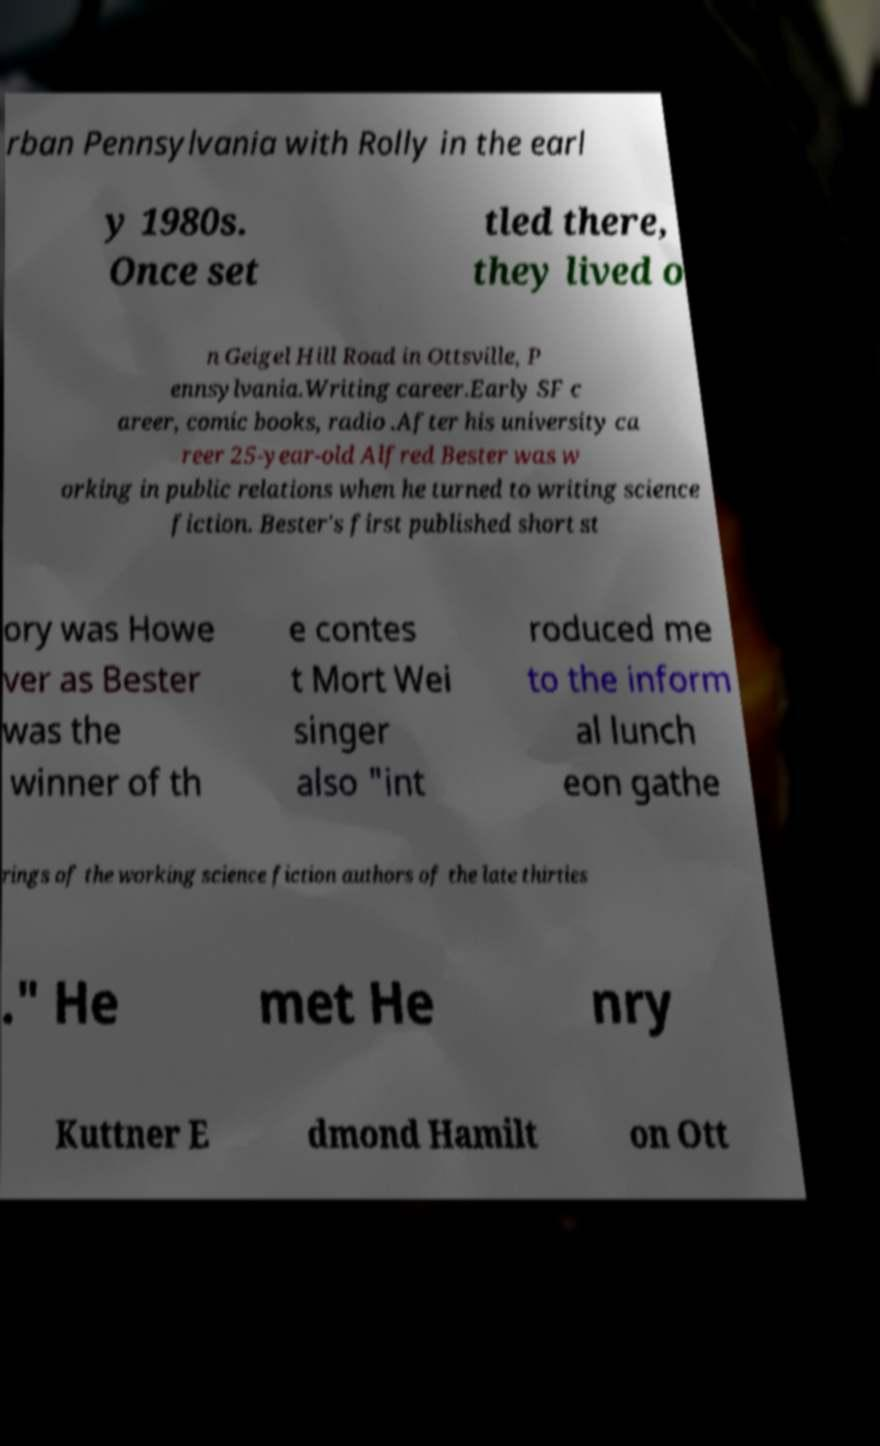There's text embedded in this image that I need extracted. Can you transcribe it verbatim? rban Pennsylvania with Rolly in the earl y 1980s. Once set tled there, they lived o n Geigel Hill Road in Ottsville, P ennsylvania.Writing career.Early SF c areer, comic books, radio .After his university ca reer 25-year-old Alfred Bester was w orking in public relations when he turned to writing science fiction. Bester's first published short st ory was Howe ver as Bester was the winner of th e contes t Mort Wei singer also "int roduced me to the inform al lunch eon gathe rings of the working science fiction authors of the late thirties ." He met He nry Kuttner E dmond Hamilt on Ott 